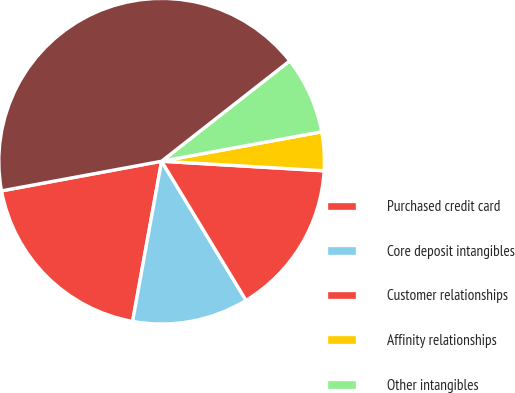<chart> <loc_0><loc_0><loc_500><loc_500><pie_chart><fcel>Purchased credit card<fcel>Core deposit intangibles<fcel>Customer relationships<fcel>Affinity relationships<fcel>Other intangibles<fcel>Total intangible assets<nl><fcel>19.23%<fcel>11.53%<fcel>15.38%<fcel>3.83%<fcel>7.68%<fcel>42.33%<nl></chart> 